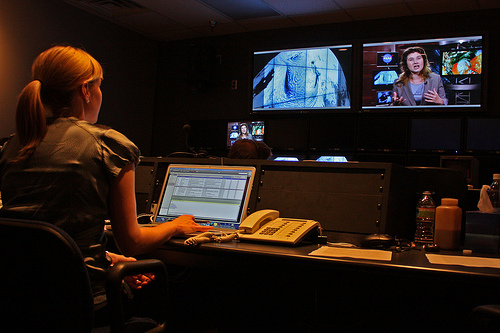Can you describe the setting of this workspace? Certainly, this workspace appears to be a professional media editing studio. There are numerous screens displaying various pieces of content, suggesting multimedia work. The lighting is dim, typical for environments where video quality is closely monitored. 